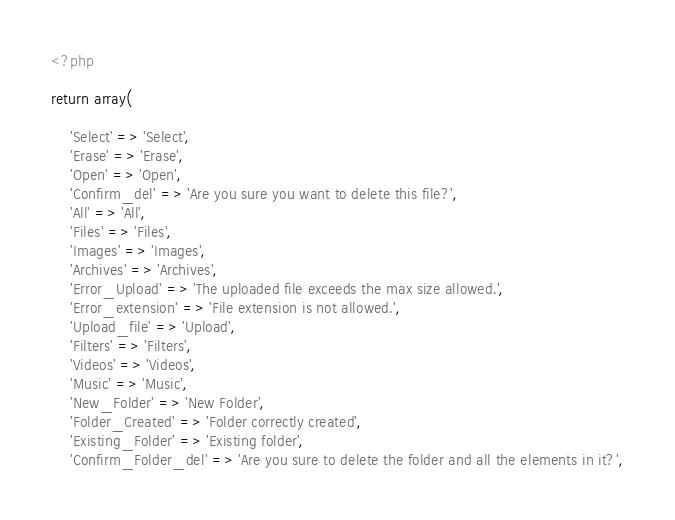Convert code to text. <code><loc_0><loc_0><loc_500><loc_500><_PHP_><?php

return array(

	'Select' => 'Select',
	'Erase' => 'Erase',
	'Open' => 'Open',
	'Confirm_del' => 'Are you sure you want to delete this file?',
	'All' => 'All',
	'Files' => 'Files',
	'Images' => 'Images',
	'Archives' => 'Archives',
	'Error_Upload' => 'The uploaded file exceeds the max size allowed.',
	'Error_extension' => 'File extension is not allowed.',
	'Upload_file' => 'Upload',
	'Filters' => 'Filters',
	'Videos' => 'Videos',
	'Music' => 'Music',
	'New_Folder' => 'New Folder',
	'Folder_Created' => 'Folder correctly created',
	'Existing_Folder' => 'Existing folder',
	'Confirm_Folder_del' => 'Are you sure to delete the folder and all the elements in it?',</code> 